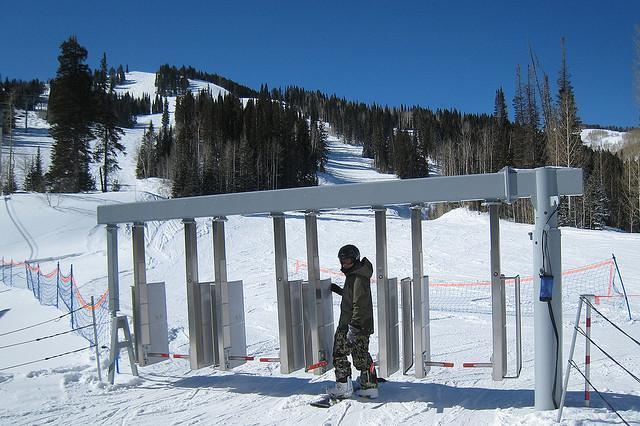What is the skier passing through?
Choose the correct response, then elucidate: 'Answer: answer
Rationale: rationale.'
Options: Security, ride, inspection, gate. Answer: gate.
Rationale: A gate is typically something you might have to go through to get to your destination. it is clear that the skier is walking through a gate; there are no rides visible and it's clear that there are no inspection or security issues here. 